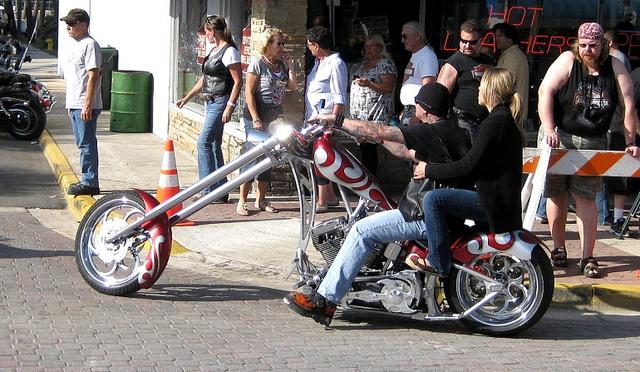What color is the trash can?
Answer briefly. Green. What does the neon sign read?
Short answer required. Hot leathers. How many people are on the motorcycle?
Give a very brief answer. 2. What design is painted on the motorcycle?
Keep it brief. Swirls. 